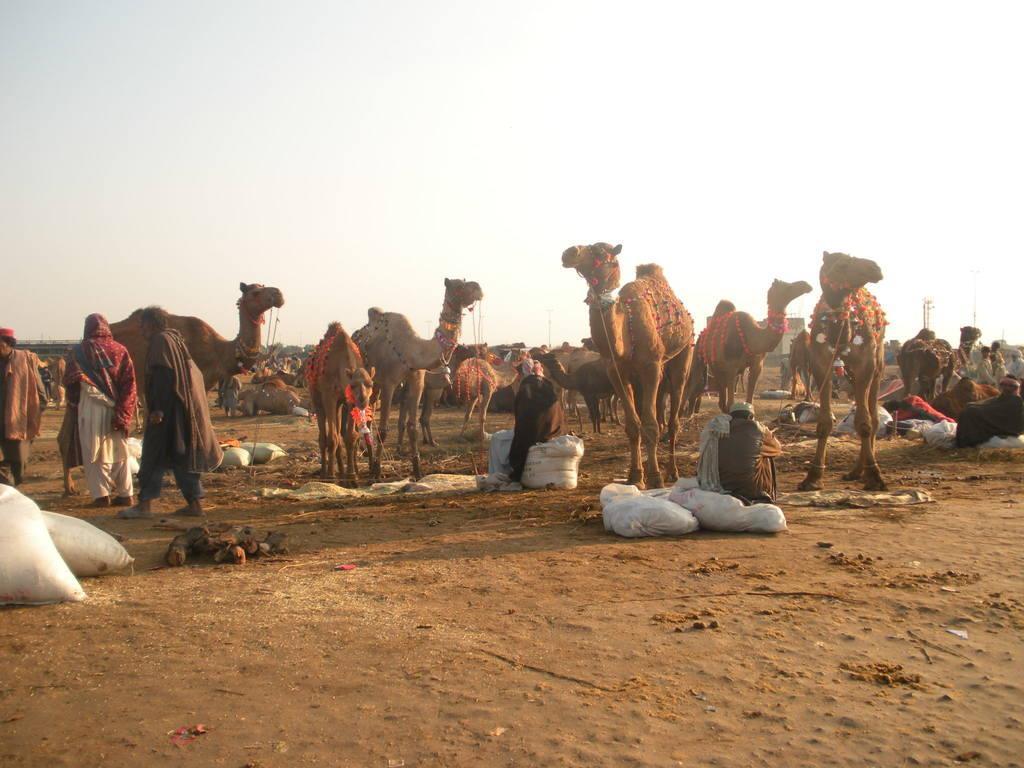Describe this image in one or two sentences. In this image we can see some group of camels, there are some persons standing and some are sitting on the ground and top of the image there is clear sky. 